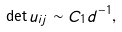<formula> <loc_0><loc_0><loc_500><loc_500>\det u _ { i j } \sim C _ { 1 } d ^ { - 1 } ,</formula> 